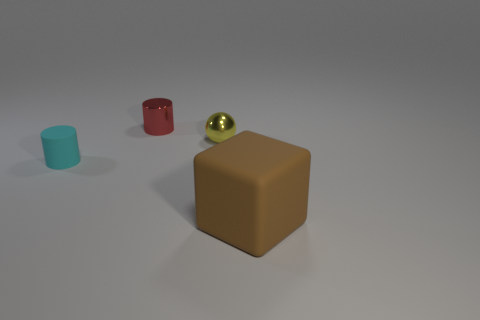Are there any other things that have the same size as the block?
Provide a succinct answer. No. How many small things are either brown cubes or green matte spheres?
Give a very brief answer. 0. Is the number of small red metallic things that are in front of the tiny cyan matte cylinder the same as the number of rubber cylinders that are behind the small yellow ball?
Make the answer very short. Yes. How many other objects are there of the same color as the tiny shiny sphere?
Your response must be concise. 0. Is the number of tiny balls behind the small sphere the same as the number of tiny things?
Provide a succinct answer. No. Do the brown object and the cyan matte cylinder have the same size?
Keep it short and to the point. No. The thing that is in front of the yellow shiny sphere and on the right side of the red shiny thing is made of what material?
Give a very brief answer. Rubber. What number of brown matte things have the same shape as the red object?
Provide a short and direct response. 0. What material is the small cylinder that is behind the small yellow metallic object?
Provide a short and direct response. Metal. Are there fewer brown blocks left of the small matte cylinder than tiny brown objects?
Provide a short and direct response. No. 